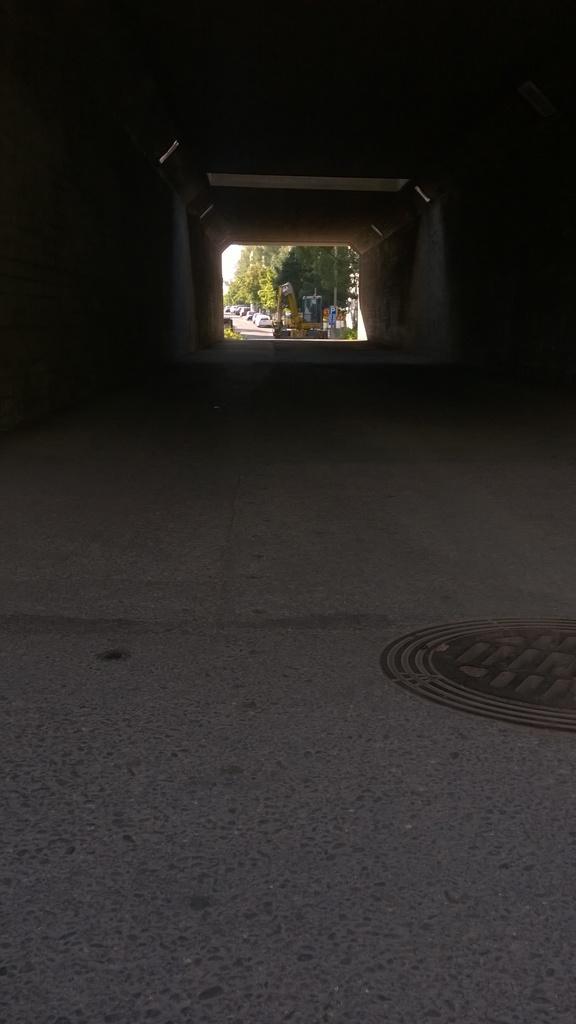Describe this image in one or two sentences. In this picture there is a subway at the top side of the image and there are cars and trees in the background area of the image. 